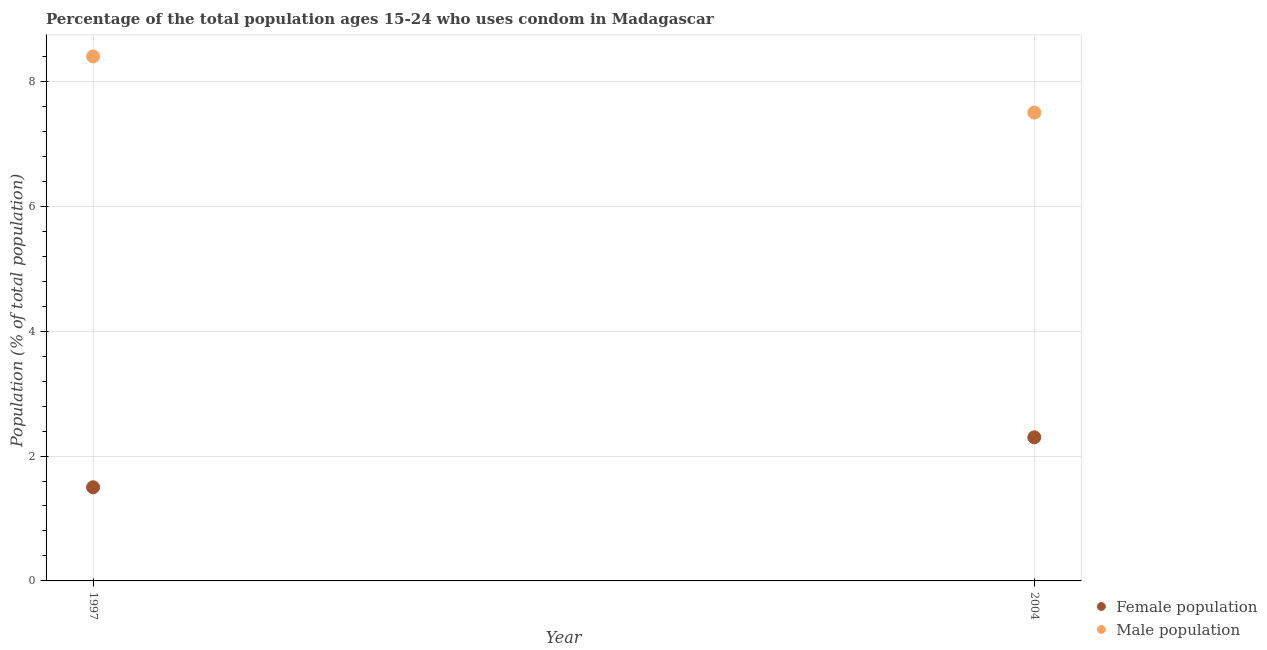How many different coloured dotlines are there?
Your answer should be very brief. 2. Across all years, what is the minimum male population?
Provide a short and direct response. 7.5. In which year was the male population maximum?
Provide a short and direct response. 1997. What is the total female population in the graph?
Offer a very short reply. 3.8. What is the difference between the female population in 1997 and that in 2004?
Ensure brevity in your answer.  -0.8. What is the difference between the female population in 1997 and the male population in 2004?
Make the answer very short. -6. What is the average male population per year?
Your answer should be very brief. 7.95. What is the ratio of the male population in 1997 to that in 2004?
Ensure brevity in your answer.  1.12. Is the male population in 1997 less than that in 2004?
Offer a very short reply. No. Does the male population monotonically increase over the years?
Give a very brief answer. No. Is the female population strictly less than the male population over the years?
Give a very brief answer. Yes. What is the difference between two consecutive major ticks on the Y-axis?
Keep it short and to the point. 2. Are the values on the major ticks of Y-axis written in scientific E-notation?
Make the answer very short. No. Does the graph contain any zero values?
Keep it short and to the point. No. Where does the legend appear in the graph?
Provide a succinct answer. Bottom right. How are the legend labels stacked?
Your response must be concise. Vertical. What is the title of the graph?
Your answer should be compact. Percentage of the total population ages 15-24 who uses condom in Madagascar. What is the label or title of the X-axis?
Ensure brevity in your answer.  Year. What is the label or title of the Y-axis?
Ensure brevity in your answer.  Population (% of total population) . What is the Population (% of total population)  of Female population in 2004?
Make the answer very short. 2.3. Across all years, what is the minimum Population (% of total population)  of Female population?
Your response must be concise. 1.5. What is the total Population (% of total population)  of Female population in the graph?
Provide a short and direct response. 3.8. What is the total Population (% of total population)  of Male population in the graph?
Provide a succinct answer. 15.9. What is the difference between the Population (% of total population)  in Female population in 1997 and that in 2004?
Make the answer very short. -0.8. What is the difference between the Population (% of total population)  in Male population in 1997 and that in 2004?
Keep it short and to the point. 0.9. What is the difference between the Population (% of total population)  of Female population in 1997 and the Population (% of total population)  of Male population in 2004?
Ensure brevity in your answer.  -6. What is the average Population (% of total population)  in Male population per year?
Your response must be concise. 7.95. In the year 1997, what is the difference between the Population (% of total population)  in Female population and Population (% of total population)  in Male population?
Give a very brief answer. -6.9. What is the ratio of the Population (% of total population)  of Female population in 1997 to that in 2004?
Provide a succinct answer. 0.65. What is the ratio of the Population (% of total population)  in Male population in 1997 to that in 2004?
Your answer should be compact. 1.12. What is the difference between the highest and the second highest Population (% of total population)  in Female population?
Ensure brevity in your answer.  0.8. What is the difference between the highest and the lowest Population (% of total population)  in Female population?
Offer a terse response. 0.8. What is the difference between the highest and the lowest Population (% of total population)  in Male population?
Offer a terse response. 0.9. 